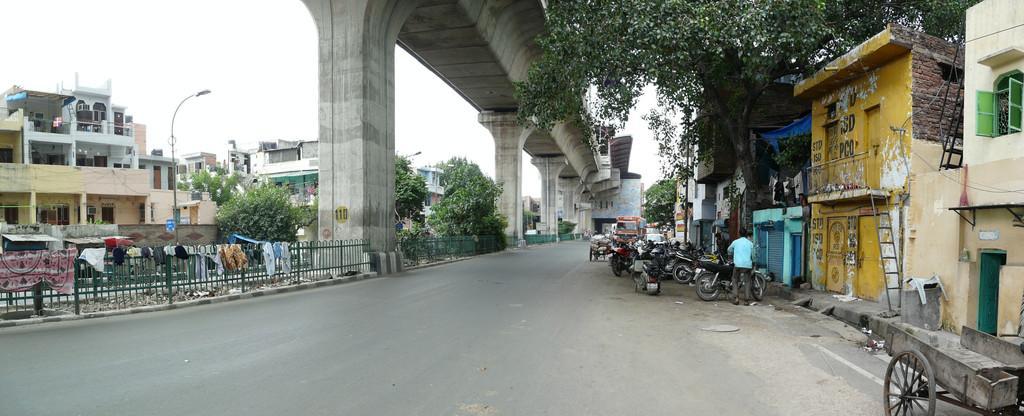Could you give a brief overview of what you see in this image? In this image we can see vehicles on the road and there are trees. On the right there is a cart and we can see a man. In the background there are buildings, trees, poles and sky we can see a bridge. On the left there are clothes on the fence. 